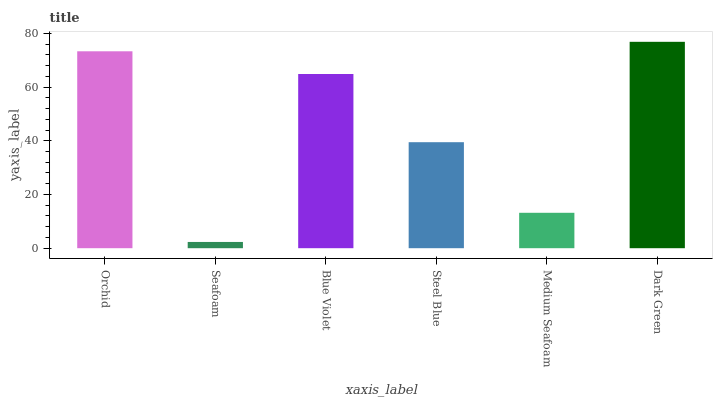Is Seafoam the minimum?
Answer yes or no. Yes. Is Dark Green the maximum?
Answer yes or no. Yes. Is Blue Violet the minimum?
Answer yes or no. No. Is Blue Violet the maximum?
Answer yes or no. No. Is Blue Violet greater than Seafoam?
Answer yes or no. Yes. Is Seafoam less than Blue Violet?
Answer yes or no. Yes. Is Seafoam greater than Blue Violet?
Answer yes or no. No. Is Blue Violet less than Seafoam?
Answer yes or no. No. Is Blue Violet the high median?
Answer yes or no. Yes. Is Steel Blue the low median?
Answer yes or no. Yes. Is Medium Seafoam the high median?
Answer yes or no. No. Is Seafoam the low median?
Answer yes or no. No. 